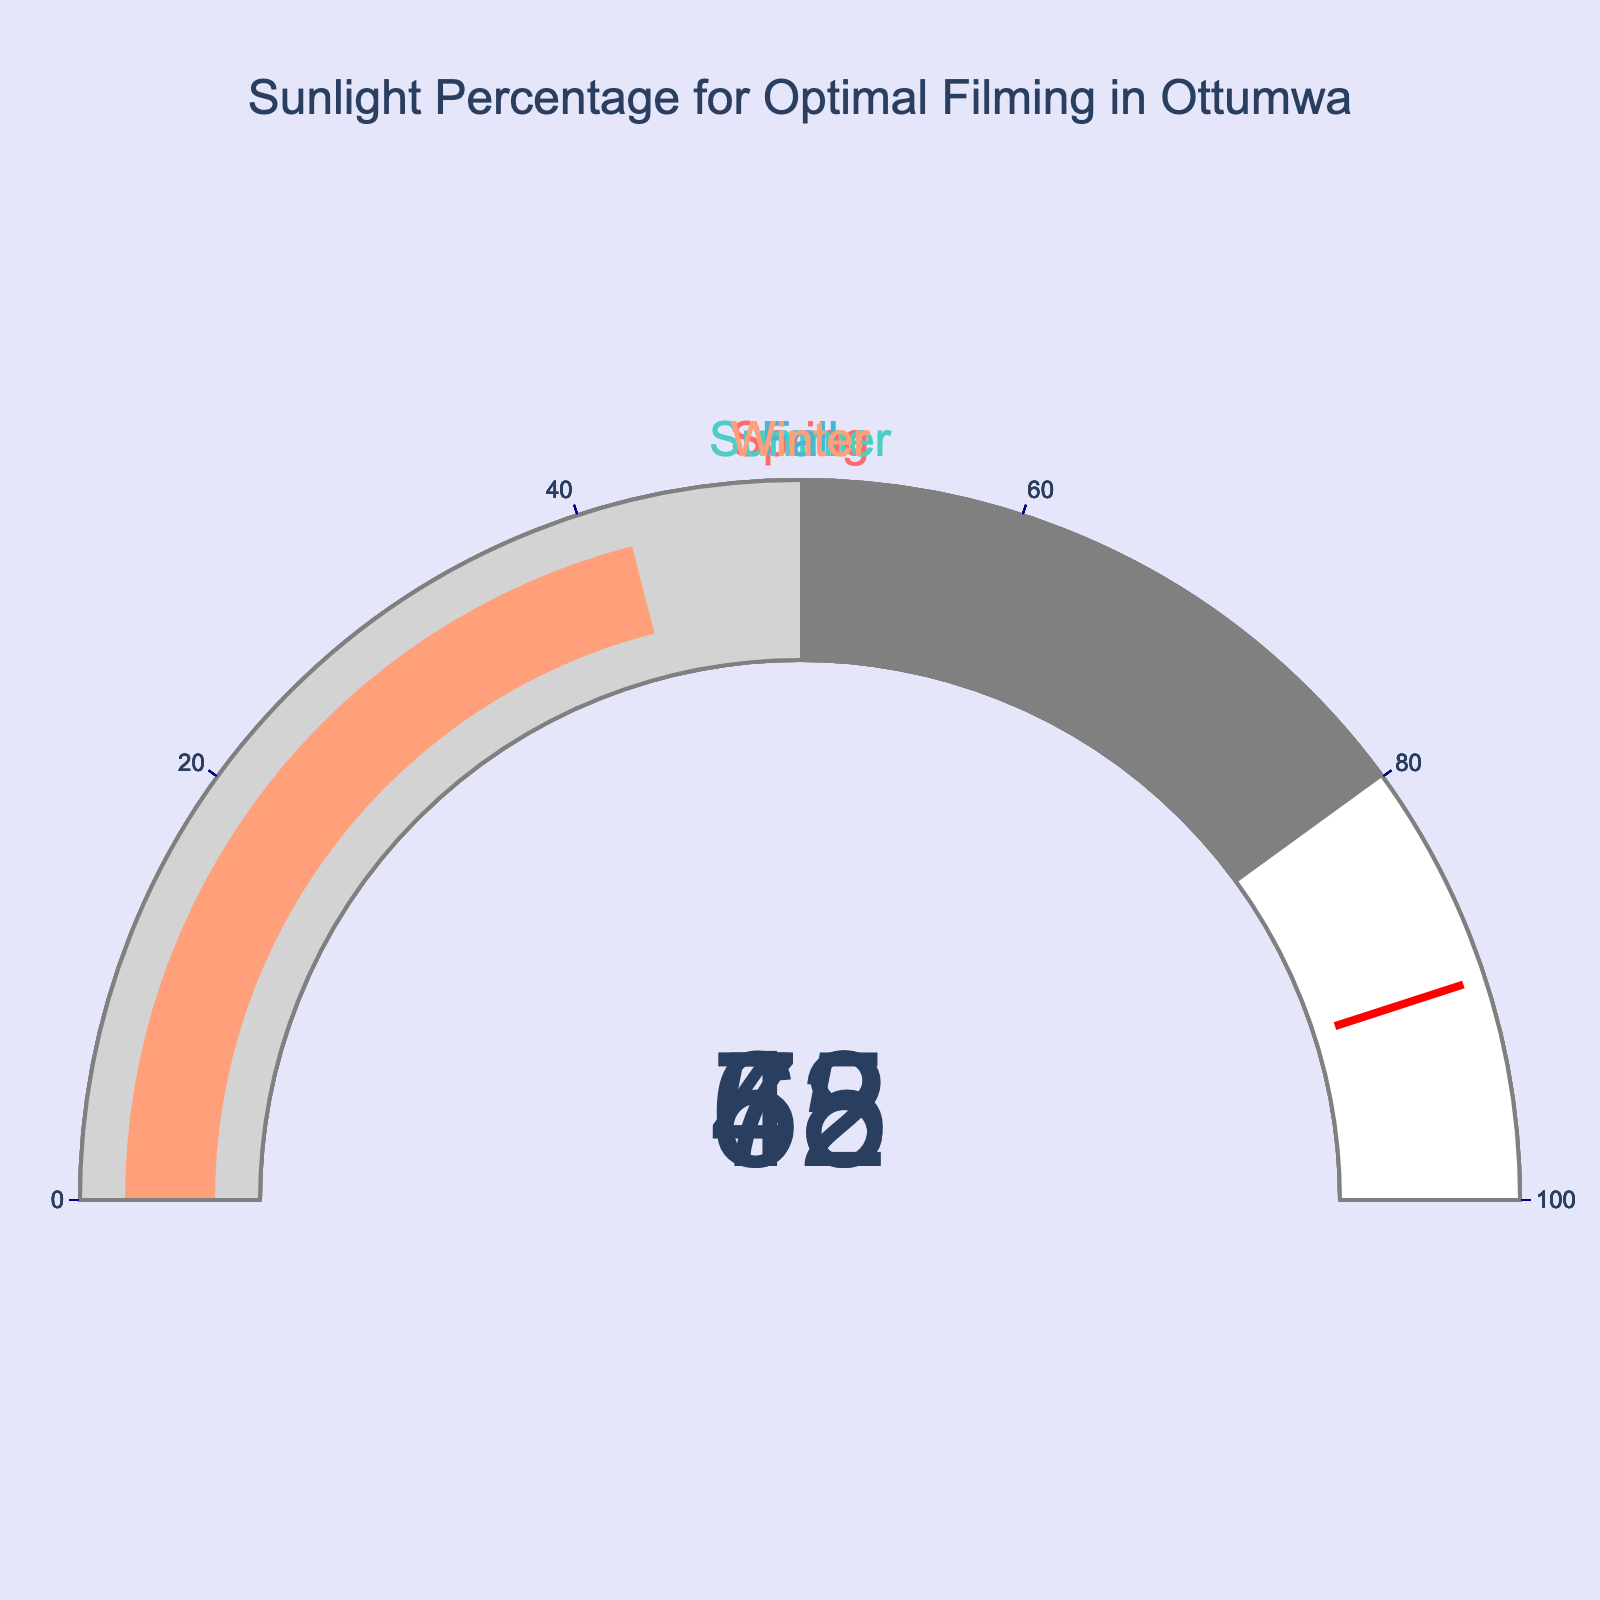Which season has the highest sunlight percentage? The gauge for the summer season displays the highest value.
Answer: Summer What's the title of the chart? The title is displayed at the top center of the chart.
Answer: Sunlight Percentage for Optimal Filming in Ottumwa Which season has the lowest sunlight percentage? The gauge for the winter season shows the lowest value.
Answer: Winter By how much does the sunlight percentage in summer exceed that in winter? Summer has 78%, and winter has 42%. The difference is 78% - 42% = 36%.
Answer: 36% What is the average sunlight percentage across all seasons? Add the percentages: 65% + 78% + 58% + 42% = 243%. Divide by the number of seasons: 243% / 4 = 60.75%.
Answer: 60.75% Which two seasons have sunlight percentages that are closer to each other? Compare the differences: Spring-Fall (65%-58%=7%), Spring-Winter (65%-42%=23%), Spring-Summer (78%-65%=13%), Summer-Winter (78%-42%=36%), and Summer-Fall (78%-58%=20%). The smallest difference is between Spring and Fall (7%).
Answer: Spring and Fall How many seasons have a sunlight percentage below 60%? Count the number of gauges with values below 60%: Fall (58%) and Winter (42%).
Answer: 2 Is the sunlight percentage in spring closer to 0% or to 100%? The spring percentage is 65%, which is closer to 100% than 0%.
Answer: 100% If the threshold for optimal filming is set at 70%, how many seasons meet or exceed this threshold? Only the summer season meets or exceeds 70% with its 78%.
Answer: 1 